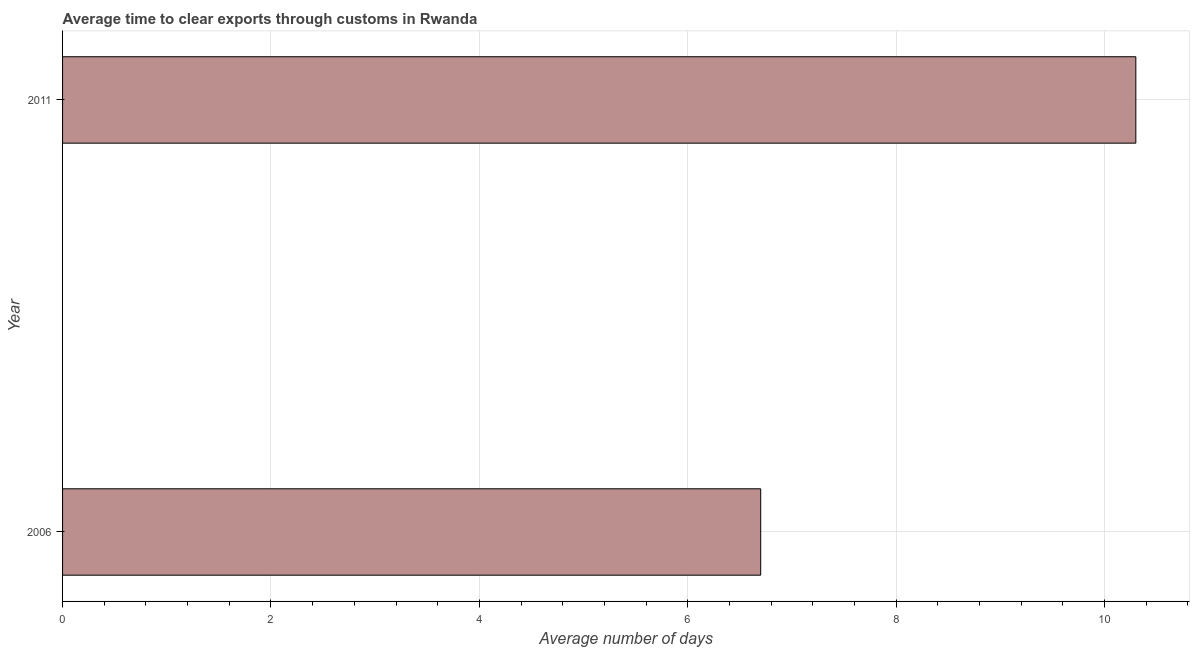Does the graph contain any zero values?
Make the answer very short. No. What is the title of the graph?
Provide a succinct answer. Average time to clear exports through customs in Rwanda. What is the label or title of the X-axis?
Ensure brevity in your answer.  Average number of days. What is the label or title of the Y-axis?
Offer a very short reply. Year. What is the time to clear exports through customs in 2011?
Offer a terse response. 10.3. Across all years, what is the maximum time to clear exports through customs?
Make the answer very short. 10.3. Across all years, what is the minimum time to clear exports through customs?
Provide a succinct answer. 6.7. What is the sum of the time to clear exports through customs?
Offer a very short reply. 17. What is the difference between the time to clear exports through customs in 2006 and 2011?
Provide a succinct answer. -3.6. Do a majority of the years between 2011 and 2006 (inclusive) have time to clear exports through customs greater than 6.8 days?
Make the answer very short. No. What is the ratio of the time to clear exports through customs in 2006 to that in 2011?
Ensure brevity in your answer.  0.65. How many bars are there?
Offer a terse response. 2. Are all the bars in the graph horizontal?
Offer a very short reply. Yes. What is the difference between the Average number of days in 2006 and 2011?
Your answer should be very brief. -3.6. What is the ratio of the Average number of days in 2006 to that in 2011?
Your answer should be very brief. 0.65. 